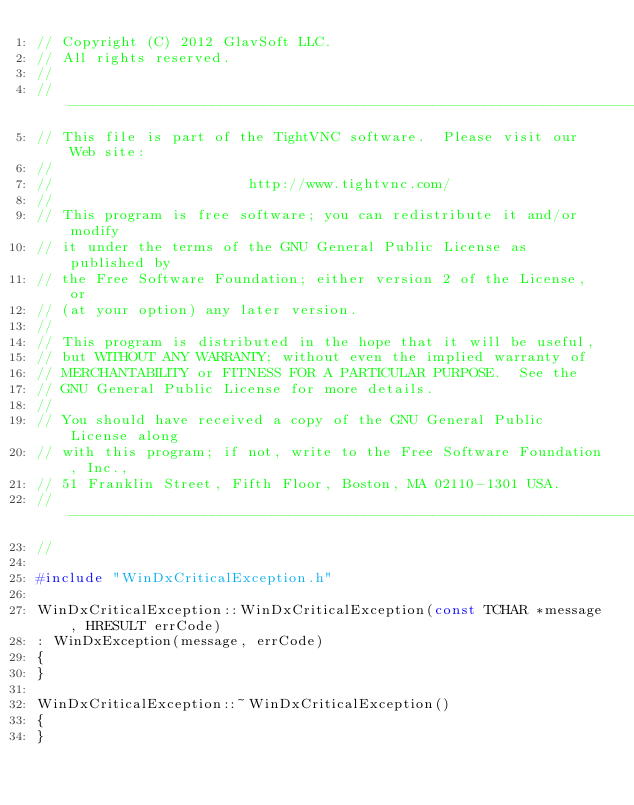Convert code to text. <code><loc_0><loc_0><loc_500><loc_500><_C++_>// Copyright (C) 2012 GlavSoft LLC.
// All rights reserved.
//
//-------------------------------------------------------------------------
// This file is part of the TightVNC software.  Please visit our Web site:
//
//                       http://www.tightvnc.com/
//
// This program is free software; you can redistribute it and/or modify
// it under the terms of the GNU General Public License as published by
// the Free Software Foundation; either version 2 of the License, or
// (at your option) any later version.
//
// This program is distributed in the hope that it will be useful,
// but WITHOUT ANY WARRANTY; without even the implied warranty of
// MERCHANTABILITY or FITNESS FOR A PARTICULAR PURPOSE.  See the
// GNU General Public License for more details.
//
// You should have received a copy of the GNU General Public License along
// with this program; if not, write to the Free Software Foundation, Inc.,
// 51 Franklin Street, Fifth Floor, Boston, MA 02110-1301 USA.
//-------------------------------------------------------------------------
//

#include "WinDxCriticalException.h"

WinDxCriticalException::WinDxCriticalException(const TCHAR *message, HRESULT errCode)
: WinDxException(message, errCode)
{
}

WinDxCriticalException::~WinDxCriticalException()
{
}
</code> 